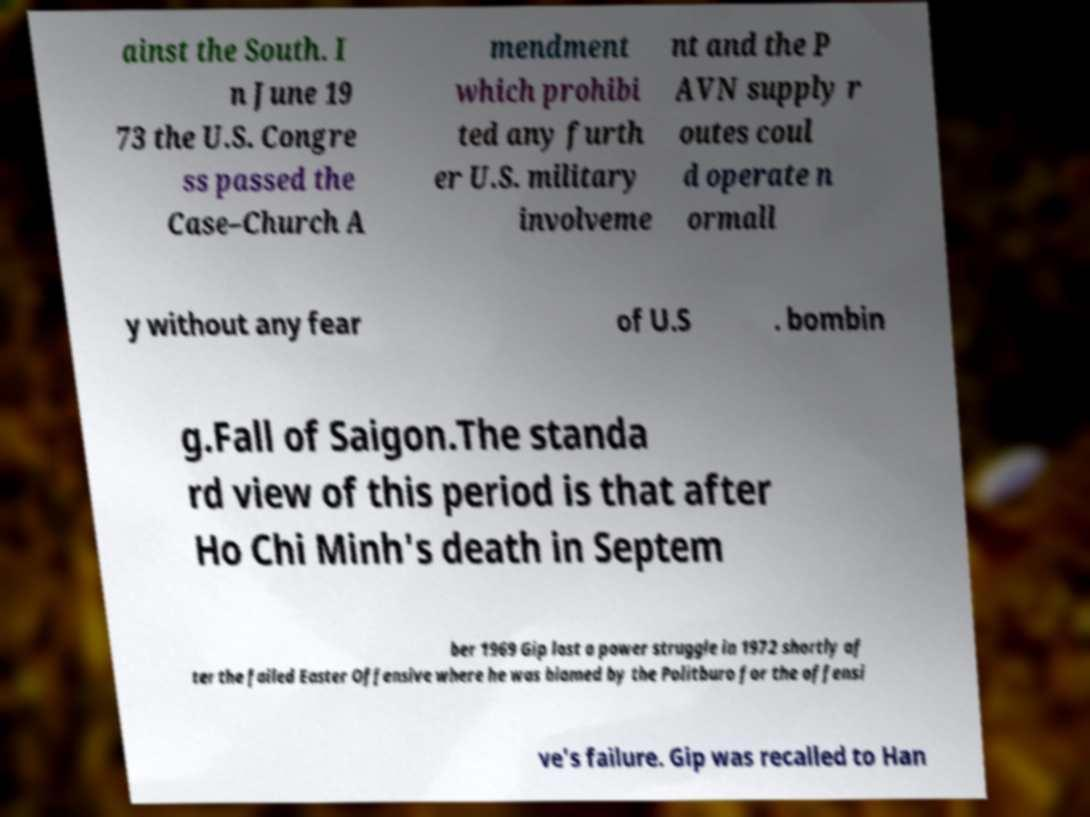Can you read and provide the text displayed in the image?This photo seems to have some interesting text. Can you extract and type it out for me? ainst the South. I n June 19 73 the U.S. Congre ss passed the Case–Church A mendment which prohibi ted any furth er U.S. military involveme nt and the P AVN supply r outes coul d operate n ormall y without any fear of U.S . bombin g.Fall of Saigon.The standa rd view of this period is that after Ho Chi Minh's death in Septem ber 1969 Gip lost a power struggle in 1972 shortly af ter the failed Easter Offensive where he was blamed by the Politburo for the offensi ve's failure. Gip was recalled to Han 